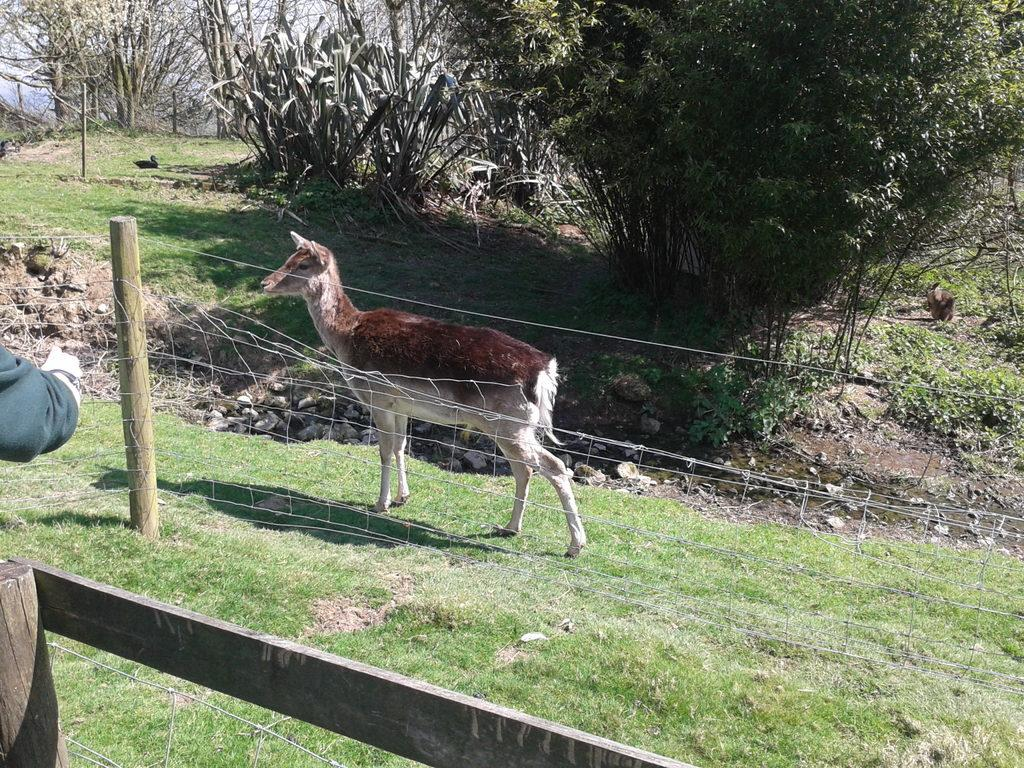What type of animal can be seen in the grass in the image? There is an animal in the grass in the image. What is the structure that separates the grass from another area in the image? There is a fence in the image. What type of vegetation is visible in the image? There are plants and trees visible in the image. What other animal can be seen in the image? There is a duck in the image. What color is the dress worn by the animal in the image? There is no animal wearing a dress in the image. How does the zipper on the duck's back function in the image? There is no zipper on the duck in the image. 